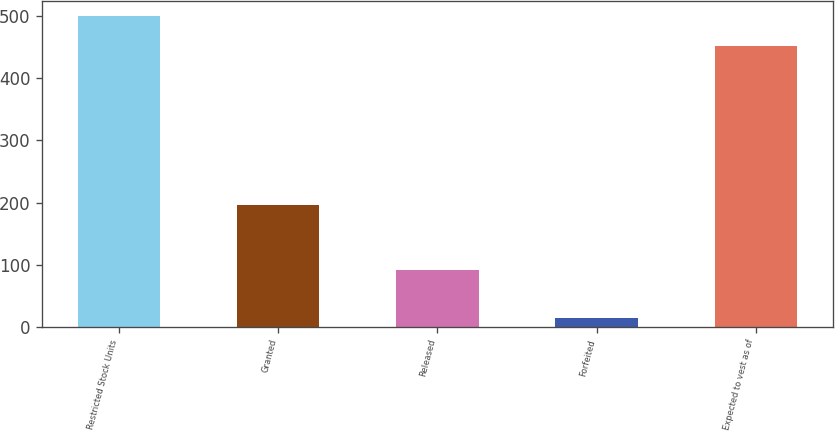<chart> <loc_0><loc_0><loc_500><loc_500><bar_chart><fcel>Restricted Stock Units<fcel>Granted<fcel>Released<fcel>Forfeited<fcel>Expected to vest as of<nl><fcel>500.2<fcel>196<fcel>91<fcel>14<fcel>452.1<nl></chart> 